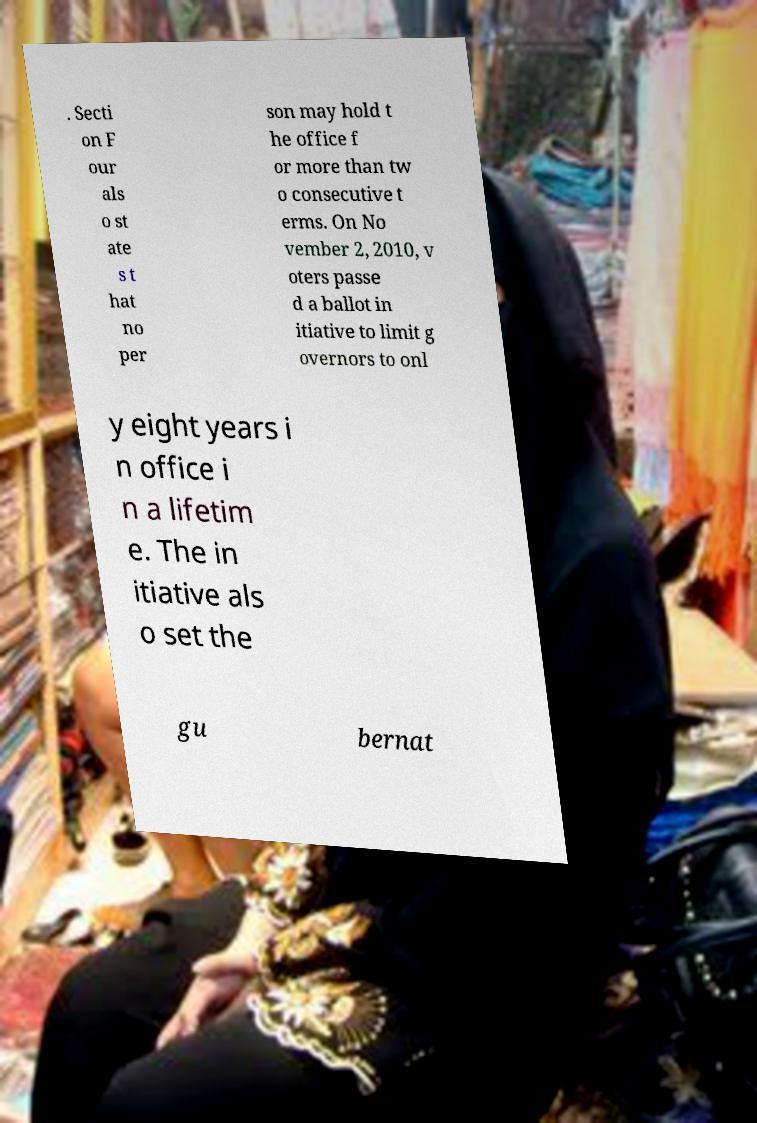There's text embedded in this image that I need extracted. Can you transcribe it verbatim? . Secti on F our als o st ate s t hat no per son may hold t he office f or more than tw o consecutive t erms. On No vember 2, 2010, v oters passe d a ballot in itiative to limit g overnors to onl y eight years i n office i n a lifetim e. The in itiative als o set the gu bernat 